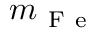Convert formula to latex. <formula><loc_0><loc_0><loc_500><loc_500>m _ { F e }</formula> 